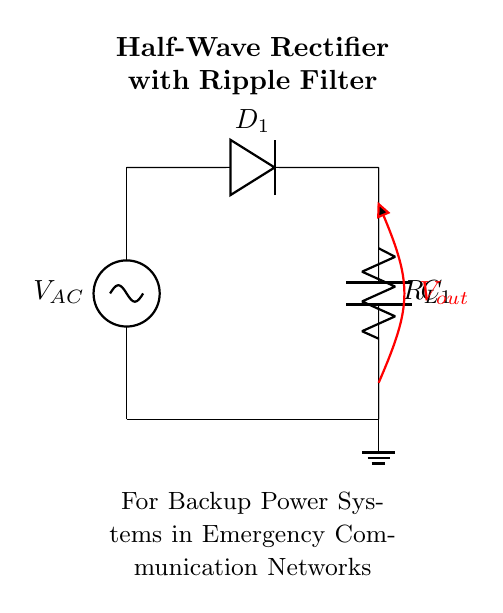What type of rectifier is shown in the diagram? The diagram displays a half-wave rectifier, characterized by a single diode allowing current to pass only during one half of the AC cycle.
Answer: Half-wave What is the role of the diode in this circuit? The diode's role is to allow current to flow in one direction, effectively blocking the negative half of the AC signal, thus converting it into a pulsating DC output.
Answer: Allow current flow What component is used for filtering ripple voltage? The component used for filtering ripple voltage is the capacitor, which smooths out fluctuations in the DC voltage by storing and releasing energy.
Answer: Capacitor What is denoted by Vout in the diagram? Vout represents the output voltage across the load resistor and capacitor, indicating the voltage available for use in the backup power system.
Answer: Output voltage How does the capacitor affect the output voltage? The capacitor reduces voltage ripple by charging during the peaks of the output voltage and discharging during the valleys, leading to a more stable DC output.
Answer: Reduces ripple What is the function of the load resistor in this circuit? The load resistor determines the amount of current drawn from the rectified output; its resistance value affects the overall voltage and power available to the connected circuit.
Answer: Load resistor What happens to the signal during the negative half cycle of input AC? During the negative half cycle of input AC, the diode is reverse-biased and prevents current flow, resulting in zero output voltage for that portion of the cycle.
Answer: Zero output 